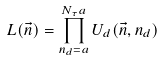<formula> <loc_0><loc_0><loc_500><loc_500>L ( \vec { n } ) = \prod _ { n _ { d } = a } ^ { N _ { \tau } a } U _ { d } ( \vec { n } , n _ { d } )</formula> 